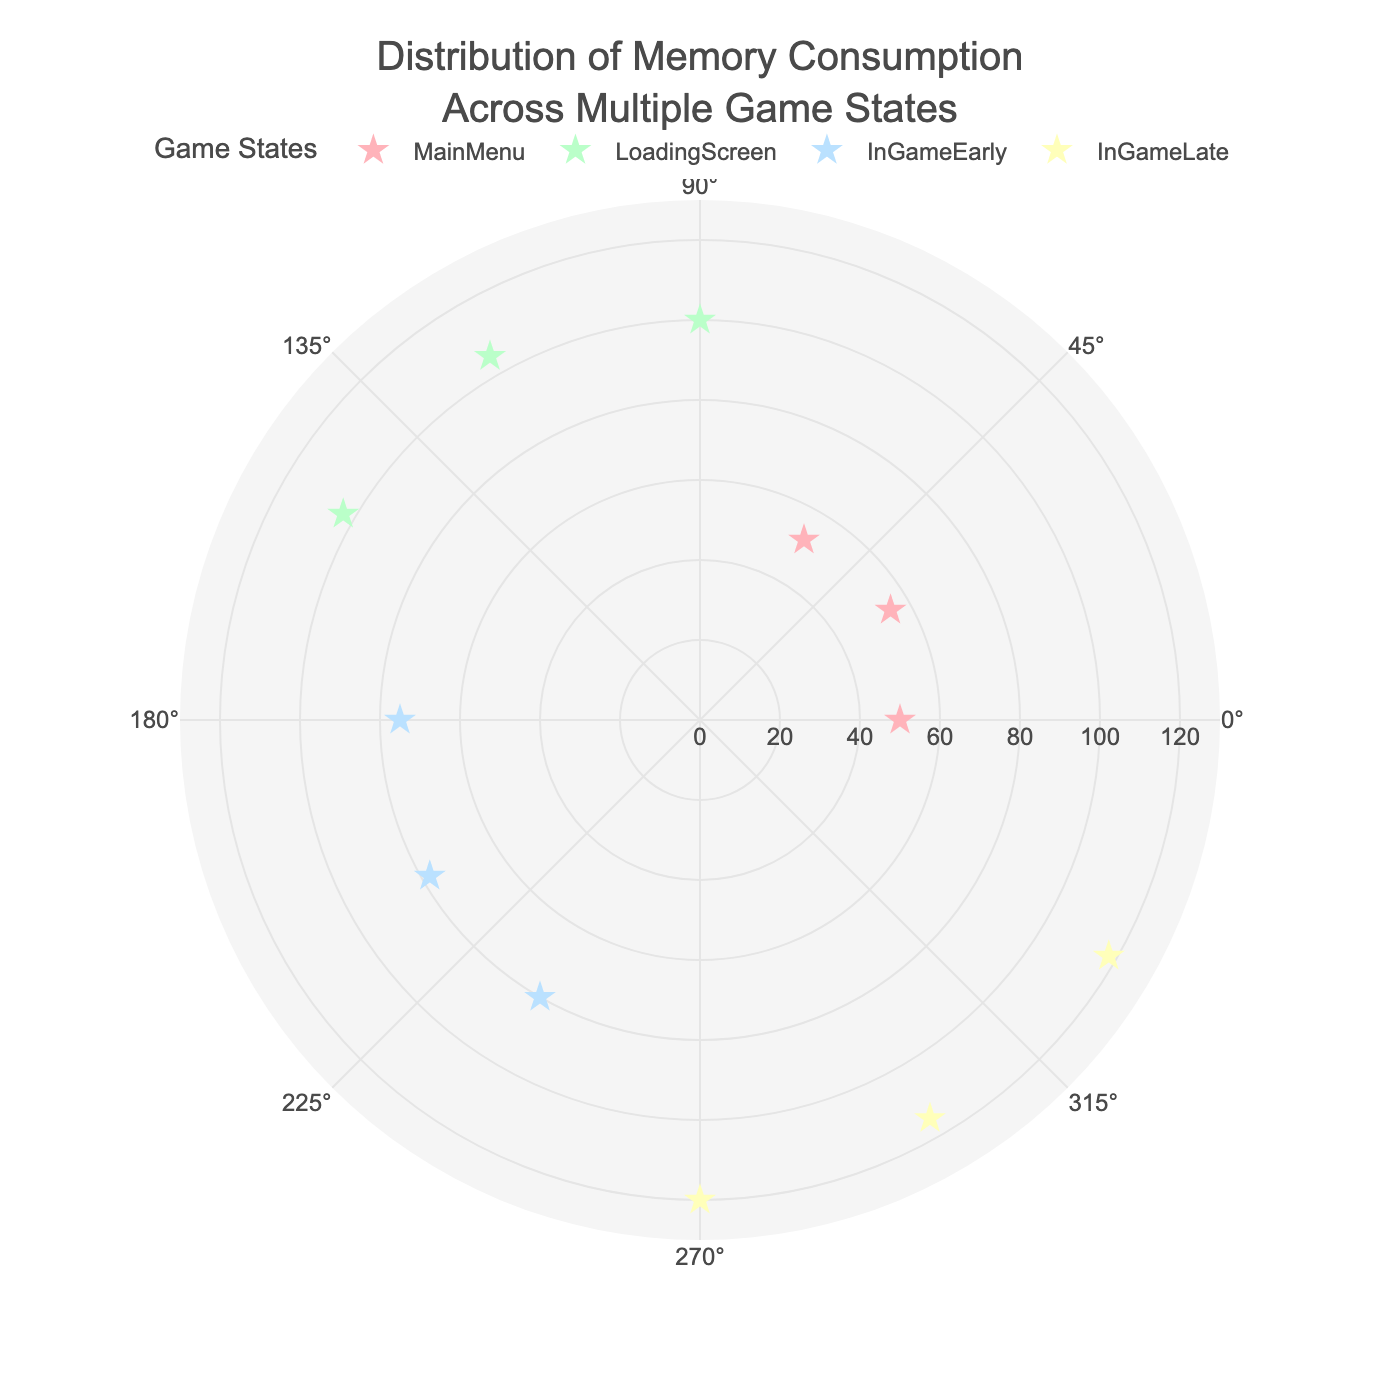What's the title of the figure? The title is the text at the top of the figure, often providing an overview of what the figure represents.
Answer: Distribution of Memory Consumption Across Multiple Game States What is the range of the radial axis? The radial axis range indicates the span of the memory consumption values from the center outward. By examining the radial axis labels on the figure, we can see the minimum and maximum values.
Answer: 0 to 130 How many data points are there in the Main Menu state? By counting the markers in the figure labeled as "MainMenu," we find the total number of data points for this state.
Answer: 3 Which game state shows the highest memory consumption, and what is the value? We look for the data point that appears furthest from the center and note its label. This point represents the highest memory consumption. According to the hover information, it belongs to the LoadingScreen state at 105 MB.
Answer: LoadingScreen, 105 MB What is the average memory consumption for the InGameEarly state? We sum all memory consumption values for the InGameEarly state and divide by the number of data points: (75 + 78 + 80) / 3 = 77.67 MB.
Answer: 77.67 MB Compare the memory consumption values between InGameLate and MainMenu states. Which is generally higher? By visually comparing the distance of markers from the center between these two states, it's clear that the InGameLate markers are further out, indicating higher memory usage.
Answer: InGameLate Which data points fall at an angle of 90°? By checking the hover information of data points located along the line extending from the center at a 90° angle, we find the corresponding memory consumption values. LoadingScreen data point matches this angle with 100 MB.
Answer: LoadingScreen, 100 MB How does the memory consumption trend for LoadingScreen compare to that for MainMenu across different angles? Compare the range and distribution of memory consumption values for both states across their respective angles. LoadingScreen markers are generally higher and clustered around 100 to 105 MB, whereas MainMenu markers range from 50 to 55 MB.
Answer: LoadingScreen has a higher memory range What is the total memory consumption for all states combined? Add all the memory consumption values from all states together to get the sum: 50 + 55 + 52 + 100 + 105 + 103 + 75 + 78 + 80 + 120 + 115 + 118 = 1051 MB.
Answer: 1051 MB 